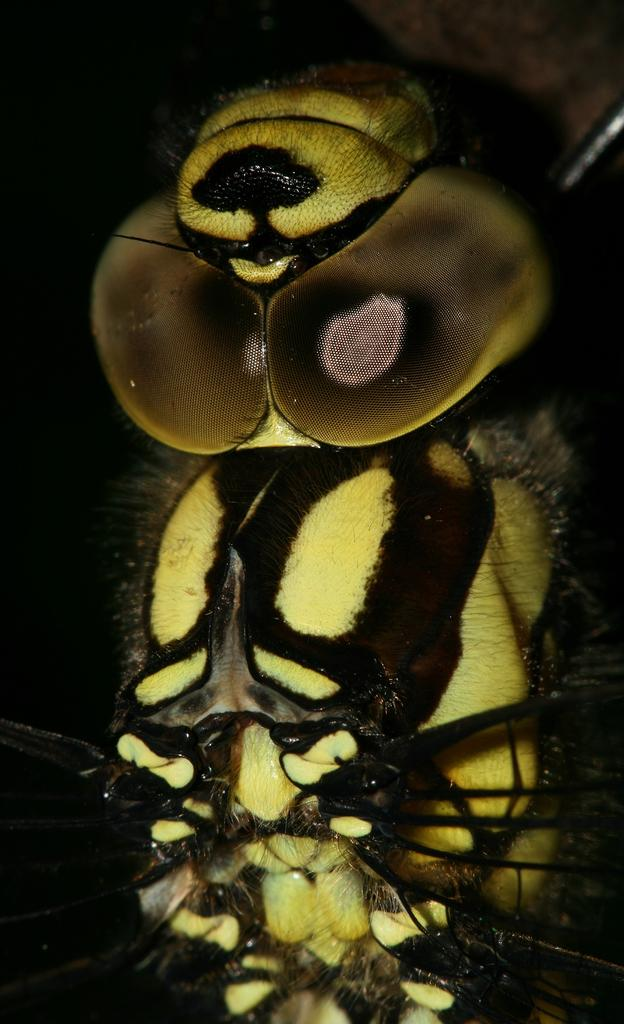What type of creature is present in the image? There is an insect in the image. What can be observed about the background of the image? The background of the image is dark. What type of face can be seen on the insect in the image? There is no face present on the insect in the image, as insects do not have facial features like humans. What type of wool is visible in the image? There is no wool present in the image. 